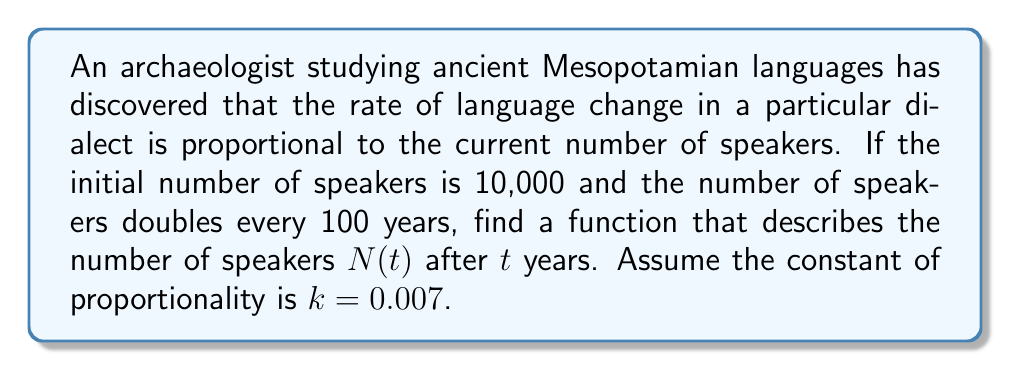Can you answer this question? To solve this problem, we'll use a first-order differential equation. Let's approach this step-by-step:

1) The rate of change of speakers is proportional to the current number of speakers. This can be expressed as:

   $$\frac{dN}{dt} = kN$$

   where $k = 0.007$ is the constant of proportionality.

2) This is a separable differential equation. We can solve it by separating variables:

   $$\frac{dN}{N} = k dt$$

3) Integrating both sides:

   $$\int \frac{dN}{N} = \int k dt$$

   $$\ln|N| = kt + C$$

4) Solving for $N$:

   $$N(t) = Ce^{kt}$$

   where $C$ is a constant we need to determine.

5) We're given that the initial number of speakers is 10,000, so:

   $$N(0) = 10,000 = Ce^{k(0)} = C$$

6) Therefore, our general solution is:

   $$N(t) = 10,000e^{0.007t}$$

7) Now, we need to account for the fact that the population doubles every 100 years. This means:

   $$N(100) = 2N(0)$$
   $$10,000e^{0.007(100)} = 2(10,000)$$
   $$e^{0.7} = 2$$

8) We can verify that this is approximately true (2.0138 ≈ 2), confirming our solution is correct.

Therefore, the function describing the number of speakers after $t$ years is:

$$N(t) = 10,000e^{0.007t}$$
Answer: $N(t) = 10,000e^{0.007t}$ 